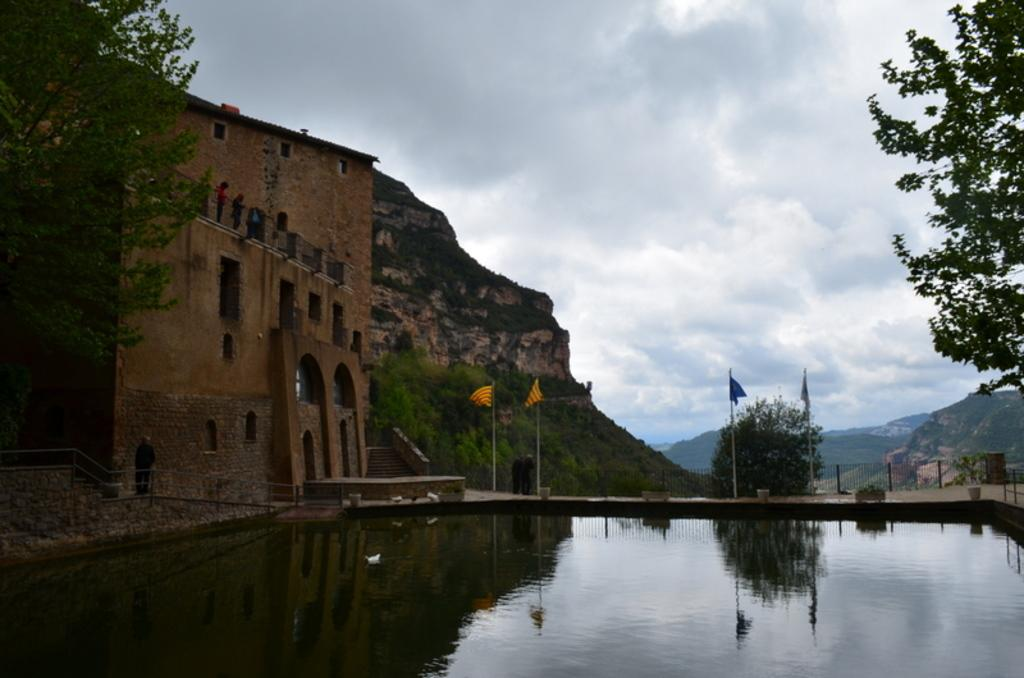What can be seen in the middle of the image? In the middle of the image, there are flags, trees, hills, a building, and poles. What is present at the bottom of the image? At the bottom of the image, there are waves, water, and a duck. What is visible at the top of the image? At the top of the image, there is sky and clouds. How many eyes does the building have in the image? The building does not have eyes; it is an inanimate object. What type of bone can be seen in the image? There are no bones present in the image. 